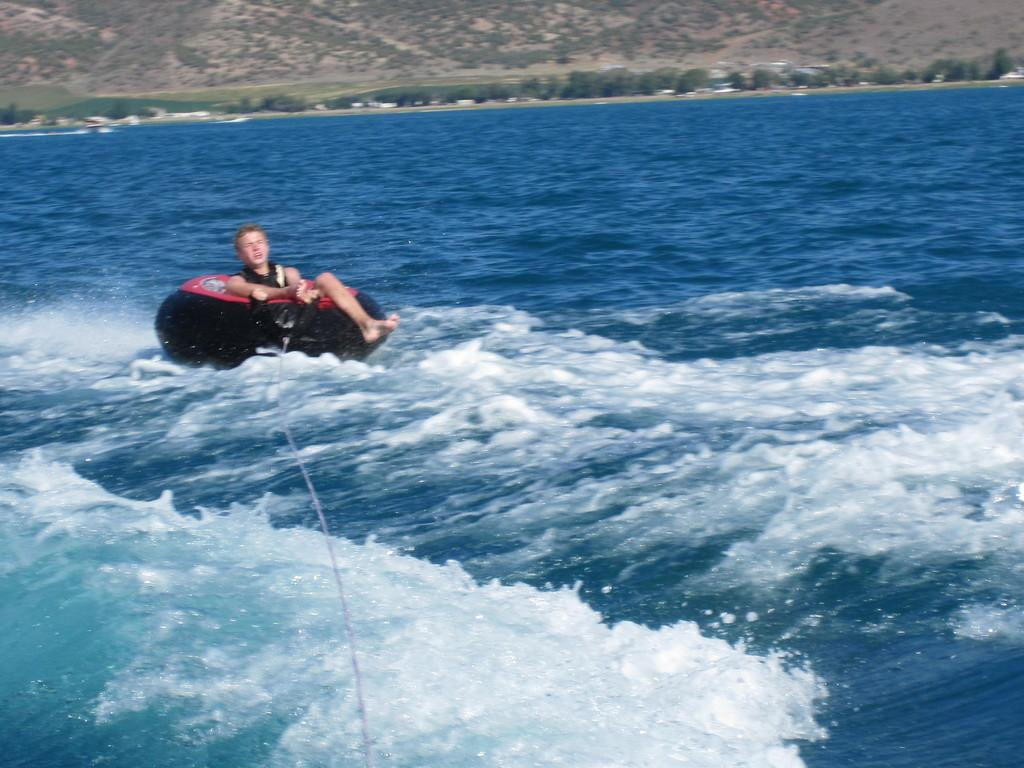What activity is the person in the image participating in? The person is tubing on the water. What can be seen in the background of the image? There are trees visible in the background of the image. Where is the volleyball court located in the image? There is no volleyball court present in the image. What is the wind blowing in the image? There is no mention of wind or blowing in the image; it only shows a person tubing on the water and trees in the background. 